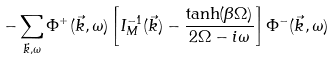<formula> <loc_0><loc_0><loc_500><loc_500>- \sum _ { \vec { k } , \omega } \Phi ^ { + } ( \vec { k } , \omega ) \left [ I _ { M } ^ { - 1 } ( \vec { k } ) - \frac { \tanh ( \beta \Omega ) } { 2 \Omega - i \omega } \right ] \Phi ^ { - } ( \vec { k } , \omega )</formula> 